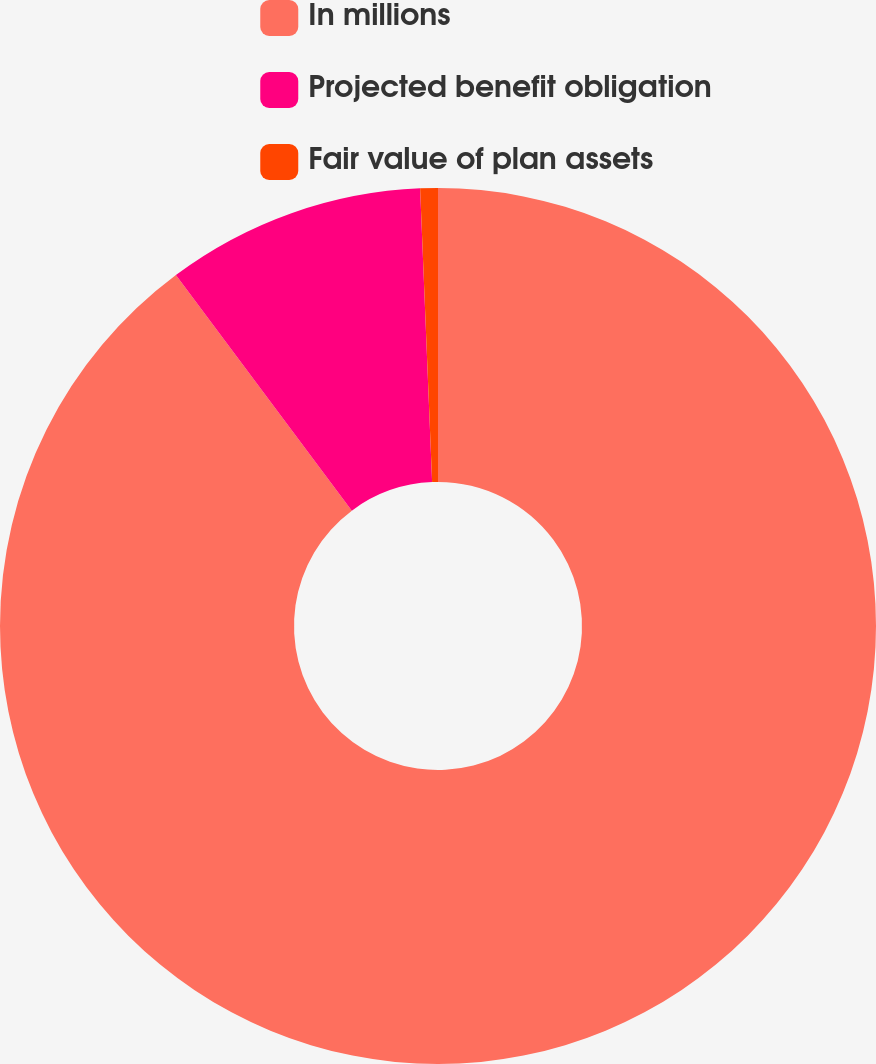Convert chart. <chart><loc_0><loc_0><loc_500><loc_500><pie_chart><fcel>In millions<fcel>Projected benefit obligation<fcel>Fair value of plan assets<nl><fcel>89.79%<fcel>9.56%<fcel>0.65%<nl></chart> 